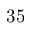Convert formula to latex. <formula><loc_0><loc_0><loc_500><loc_500>3 5</formula> 